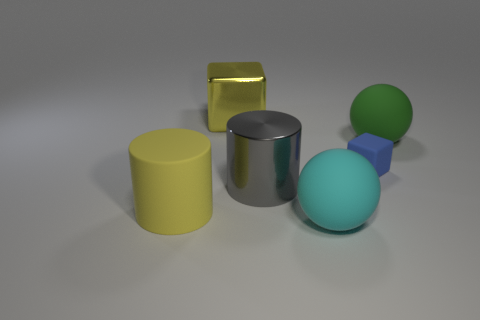Add 2 large yellow cylinders. How many objects exist? 8 Subtract all cylinders. How many objects are left? 4 Add 6 large yellow shiny cubes. How many large yellow shiny cubes exist? 7 Subtract 1 yellow blocks. How many objects are left? 5 Subtract all big green cubes. Subtract all large cyan rubber spheres. How many objects are left? 5 Add 4 big yellow matte things. How many big yellow matte things are left? 5 